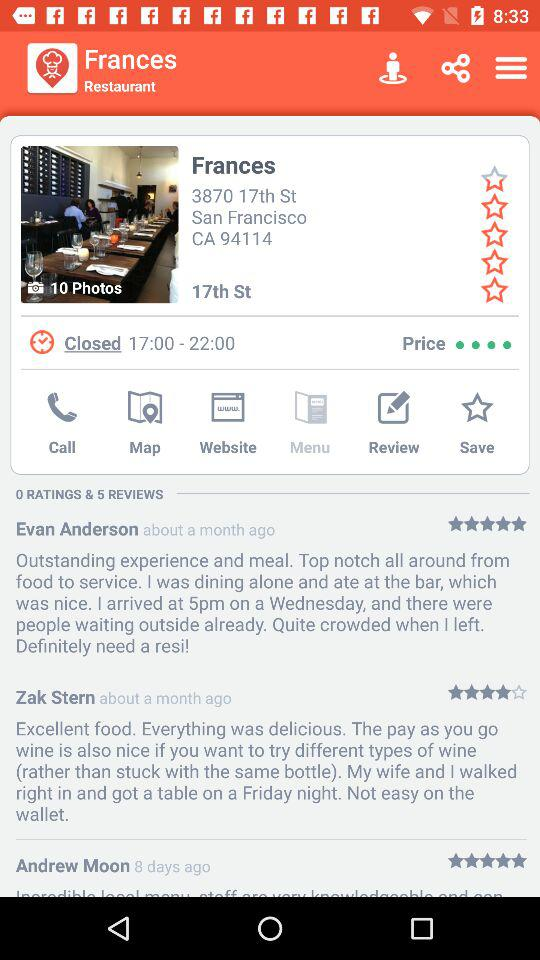How many ratings and reviews are given? There are 0 ratings and 5 reviews given. 